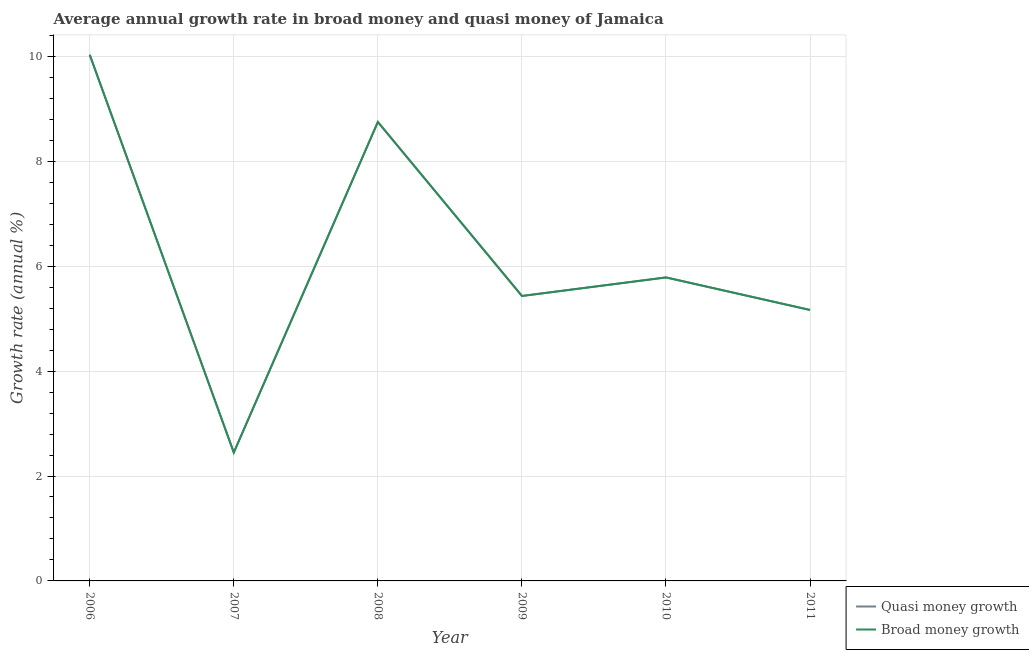Does the line corresponding to annual growth rate in quasi money intersect with the line corresponding to annual growth rate in broad money?
Provide a succinct answer. Yes. What is the annual growth rate in broad money in 2008?
Offer a terse response. 8.75. Across all years, what is the maximum annual growth rate in quasi money?
Ensure brevity in your answer.  10.03. Across all years, what is the minimum annual growth rate in broad money?
Your response must be concise. 2.45. In which year was the annual growth rate in broad money minimum?
Ensure brevity in your answer.  2007. What is the total annual growth rate in broad money in the graph?
Provide a short and direct response. 37.61. What is the difference between the annual growth rate in quasi money in 2006 and that in 2007?
Offer a terse response. 7.58. What is the difference between the annual growth rate in broad money in 2011 and the annual growth rate in quasi money in 2008?
Your answer should be very brief. -3.58. What is the average annual growth rate in broad money per year?
Make the answer very short. 6.27. In the year 2010, what is the difference between the annual growth rate in broad money and annual growth rate in quasi money?
Keep it short and to the point. 0. In how many years, is the annual growth rate in quasi money greater than 6 %?
Your response must be concise. 2. What is the ratio of the annual growth rate in broad money in 2007 to that in 2008?
Keep it short and to the point. 0.28. What is the difference between the highest and the second highest annual growth rate in quasi money?
Provide a succinct answer. 1.28. What is the difference between the highest and the lowest annual growth rate in quasi money?
Your response must be concise. 7.58. How many lines are there?
Your answer should be very brief. 2. How many years are there in the graph?
Your answer should be very brief. 6. What is the difference between two consecutive major ticks on the Y-axis?
Your response must be concise. 2. Are the values on the major ticks of Y-axis written in scientific E-notation?
Give a very brief answer. No. Where does the legend appear in the graph?
Your answer should be compact. Bottom right. What is the title of the graph?
Your answer should be very brief. Average annual growth rate in broad money and quasi money of Jamaica. What is the label or title of the Y-axis?
Give a very brief answer. Growth rate (annual %). What is the Growth rate (annual %) of Quasi money growth in 2006?
Your answer should be very brief. 10.03. What is the Growth rate (annual %) in Broad money growth in 2006?
Offer a very short reply. 10.03. What is the Growth rate (annual %) in Quasi money growth in 2007?
Your response must be concise. 2.45. What is the Growth rate (annual %) in Broad money growth in 2007?
Provide a succinct answer. 2.45. What is the Growth rate (annual %) of Quasi money growth in 2008?
Provide a succinct answer. 8.75. What is the Growth rate (annual %) of Broad money growth in 2008?
Provide a succinct answer. 8.75. What is the Growth rate (annual %) in Quasi money growth in 2009?
Ensure brevity in your answer.  5.43. What is the Growth rate (annual %) of Broad money growth in 2009?
Provide a short and direct response. 5.43. What is the Growth rate (annual %) in Quasi money growth in 2010?
Your answer should be very brief. 5.79. What is the Growth rate (annual %) in Broad money growth in 2010?
Your answer should be compact. 5.79. What is the Growth rate (annual %) of Quasi money growth in 2011?
Provide a succinct answer. 5.16. What is the Growth rate (annual %) of Broad money growth in 2011?
Give a very brief answer. 5.16. Across all years, what is the maximum Growth rate (annual %) of Quasi money growth?
Give a very brief answer. 10.03. Across all years, what is the maximum Growth rate (annual %) in Broad money growth?
Your answer should be compact. 10.03. Across all years, what is the minimum Growth rate (annual %) in Quasi money growth?
Give a very brief answer. 2.45. Across all years, what is the minimum Growth rate (annual %) of Broad money growth?
Keep it short and to the point. 2.45. What is the total Growth rate (annual %) in Quasi money growth in the graph?
Keep it short and to the point. 37.61. What is the total Growth rate (annual %) in Broad money growth in the graph?
Offer a very short reply. 37.61. What is the difference between the Growth rate (annual %) in Quasi money growth in 2006 and that in 2007?
Your answer should be very brief. 7.58. What is the difference between the Growth rate (annual %) in Broad money growth in 2006 and that in 2007?
Provide a succinct answer. 7.58. What is the difference between the Growth rate (annual %) of Quasi money growth in 2006 and that in 2008?
Provide a short and direct response. 1.28. What is the difference between the Growth rate (annual %) in Broad money growth in 2006 and that in 2008?
Make the answer very short. 1.28. What is the difference between the Growth rate (annual %) in Quasi money growth in 2006 and that in 2009?
Offer a terse response. 4.6. What is the difference between the Growth rate (annual %) in Broad money growth in 2006 and that in 2009?
Provide a succinct answer. 4.6. What is the difference between the Growth rate (annual %) in Quasi money growth in 2006 and that in 2010?
Your response must be concise. 4.24. What is the difference between the Growth rate (annual %) in Broad money growth in 2006 and that in 2010?
Ensure brevity in your answer.  4.24. What is the difference between the Growth rate (annual %) in Quasi money growth in 2006 and that in 2011?
Provide a short and direct response. 4.87. What is the difference between the Growth rate (annual %) of Broad money growth in 2006 and that in 2011?
Give a very brief answer. 4.87. What is the difference between the Growth rate (annual %) of Quasi money growth in 2007 and that in 2008?
Offer a terse response. -6.3. What is the difference between the Growth rate (annual %) in Broad money growth in 2007 and that in 2008?
Give a very brief answer. -6.3. What is the difference between the Growth rate (annual %) of Quasi money growth in 2007 and that in 2009?
Provide a succinct answer. -2.98. What is the difference between the Growth rate (annual %) of Broad money growth in 2007 and that in 2009?
Your response must be concise. -2.98. What is the difference between the Growth rate (annual %) in Quasi money growth in 2007 and that in 2010?
Offer a very short reply. -3.34. What is the difference between the Growth rate (annual %) of Broad money growth in 2007 and that in 2010?
Offer a terse response. -3.34. What is the difference between the Growth rate (annual %) of Quasi money growth in 2007 and that in 2011?
Ensure brevity in your answer.  -2.72. What is the difference between the Growth rate (annual %) in Broad money growth in 2007 and that in 2011?
Provide a succinct answer. -2.72. What is the difference between the Growth rate (annual %) in Quasi money growth in 2008 and that in 2009?
Offer a very short reply. 3.32. What is the difference between the Growth rate (annual %) in Broad money growth in 2008 and that in 2009?
Give a very brief answer. 3.32. What is the difference between the Growth rate (annual %) of Quasi money growth in 2008 and that in 2010?
Your answer should be compact. 2.96. What is the difference between the Growth rate (annual %) in Broad money growth in 2008 and that in 2010?
Keep it short and to the point. 2.96. What is the difference between the Growth rate (annual %) in Quasi money growth in 2008 and that in 2011?
Offer a very short reply. 3.58. What is the difference between the Growth rate (annual %) of Broad money growth in 2008 and that in 2011?
Offer a very short reply. 3.58. What is the difference between the Growth rate (annual %) in Quasi money growth in 2009 and that in 2010?
Your answer should be compact. -0.35. What is the difference between the Growth rate (annual %) of Broad money growth in 2009 and that in 2010?
Offer a terse response. -0.35. What is the difference between the Growth rate (annual %) in Quasi money growth in 2009 and that in 2011?
Keep it short and to the point. 0.27. What is the difference between the Growth rate (annual %) in Broad money growth in 2009 and that in 2011?
Offer a terse response. 0.27. What is the difference between the Growth rate (annual %) in Quasi money growth in 2010 and that in 2011?
Your answer should be compact. 0.62. What is the difference between the Growth rate (annual %) of Broad money growth in 2010 and that in 2011?
Provide a succinct answer. 0.62. What is the difference between the Growth rate (annual %) of Quasi money growth in 2006 and the Growth rate (annual %) of Broad money growth in 2007?
Offer a terse response. 7.58. What is the difference between the Growth rate (annual %) of Quasi money growth in 2006 and the Growth rate (annual %) of Broad money growth in 2008?
Offer a very short reply. 1.28. What is the difference between the Growth rate (annual %) of Quasi money growth in 2006 and the Growth rate (annual %) of Broad money growth in 2009?
Make the answer very short. 4.6. What is the difference between the Growth rate (annual %) in Quasi money growth in 2006 and the Growth rate (annual %) in Broad money growth in 2010?
Make the answer very short. 4.24. What is the difference between the Growth rate (annual %) in Quasi money growth in 2006 and the Growth rate (annual %) in Broad money growth in 2011?
Your response must be concise. 4.87. What is the difference between the Growth rate (annual %) in Quasi money growth in 2007 and the Growth rate (annual %) in Broad money growth in 2008?
Ensure brevity in your answer.  -6.3. What is the difference between the Growth rate (annual %) in Quasi money growth in 2007 and the Growth rate (annual %) in Broad money growth in 2009?
Make the answer very short. -2.98. What is the difference between the Growth rate (annual %) in Quasi money growth in 2007 and the Growth rate (annual %) in Broad money growth in 2010?
Your response must be concise. -3.34. What is the difference between the Growth rate (annual %) of Quasi money growth in 2007 and the Growth rate (annual %) of Broad money growth in 2011?
Your answer should be compact. -2.72. What is the difference between the Growth rate (annual %) in Quasi money growth in 2008 and the Growth rate (annual %) in Broad money growth in 2009?
Ensure brevity in your answer.  3.32. What is the difference between the Growth rate (annual %) in Quasi money growth in 2008 and the Growth rate (annual %) in Broad money growth in 2010?
Keep it short and to the point. 2.96. What is the difference between the Growth rate (annual %) in Quasi money growth in 2008 and the Growth rate (annual %) in Broad money growth in 2011?
Give a very brief answer. 3.58. What is the difference between the Growth rate (annual %) in Quasi money growth in 2009 and the Growth rate (annual %) in Broad money growth in 2010?
Keep it short and to the point. -0.35. What is the difference between the Growth rate (annual %) in Quasi money growth in 2009 and the Growth rate (annual %) in Broad money growth in 2011?
Offer a very short reply. 0.27. What is the difference between the Growth rate (annual %) in Quasi money growth in 2010 and the Growth rate (annual %) in Broad money growth in 2011?
Provide a succinct answer. 0.62. What is the average Growth rate (annual %) of Quasi money growth per year?
Offer a terse response. 6.27. What is the average Growth rate (annual %) in Broad money growth per year?
Give a very brief answer. 6.27. In the year 2006, what is the difference between the Growth rate (annual %) in Quasi money growth and Growth rate (annual %) in Broad money growth?
Provide a short and direct response. 0. In the year 2007, what is the difference between the Growth rate (annual %) of Quasi money growth and Growth rate (annual %) of Broad money growth?
Make the answer very short. 0. In the year 2008, what is the difference between the Growth rate (annual %) of Quasi money growth and Growth rate (annual %) of Broad money growth?
Keep it short and to the point. 0. In the year 2009, what is the difference between the Growth rate (annual %) of Quasi money growth and Growth rate (annual %) of Broad money growth?
Offer a terse response. 0. In the year 2010, what is the difference between the Growth rate (annual %) in Quasi money growth and Growth rate (annual %) in Broad money growth?
Make the answer very short. 0. What is the ratio of the Growth rate (annual %) in Quasi money growth in 2006 to that in 2007?
Offer a terse response. 4.1. What is the ratio of the Growth rate (annual %) of Broad money growth in 2006 to that in 2007?
Give a very brief answer. 4.1. What is the ratio of the Growth rate (annual %) in Quasi money growth in 2006 to that in 2008?
Offer a terse response. 1.15. What is the ratio of the Growth rate (annual %) of Broad money growth in 2006 to that in 2008?
Provide a succinct answer. 1.15. What is the ratio of the Growth rate (annual %) in Quasi money growth in 2006 to that in 2009?
Your answer should be very brief. 1.85. What is the ratio of the Growth rate (annual %) of Broad money growth in 2006 to that in 2009?
Your answer should be very brief. 1.85. What is the ratio of the Growth rate (annual %) in Quasi money growth in 2006 to that in 2010?
Your answer should be very brief. 1.73. What is the ratio of the Growth rate (annual %) in Broad money growth in 2006 to that in 2010?
Keep it short and to the point. 1.73. What is the ratio of the Growth rate (annual %) in Quasi money growth in 2006 to that in 2011?
Give a very brief answer. 1.94. What is the ratio of the Growth rate (annual %) in Broad money growth in 2006 to that in 2011?
Your answer should be very brief. 1.94. What is the ratio of the Growth rate (annual %) of Quasi money growth in 2007 to that in 2008?
Keep it short and to the point. 0.28. What is the ratio of the Growth rate (annual %) of Broad money growth in 2007 to that in 2008?
Your answer should be very brief. 0.28. What is the ratio of the Growth rate (annual %) in Quasi money growth in 2007 to that in 2009?
Make the answer very short. 0.45. What is the ratio of the Growth rate (annual %) in Broad money growth in 2007 to that in 2009?
Offer a very short reply. 0.45. What is the ratio of the Growth rate (annual %) of Quasi money growth in 2007 to that in 2010?
Make the answer very short. 0.42. What is the ratio of the Growth rate (annual %) in Broad money growth in 2007 to that in 2010?
Offer a terse response. 0.42. What is the ratio of the Growth rate (annual %) in Quasi money growth in 2007 to that in 2011?
Offer a terse response. 0.47. What is the ratio of the Growth rate (annual %) in Broad money growth in 2007 to that in 2011?
Ensure brevity in your answer.  0.47. What is the ratio of the Growth rate (annual %) in Quasi money growth in 2008 to that in 2009?
Keep it short and to the point. 1.61. What is the ratio of the Growth rate (annual %) of Broad money growth in 2008 to that in 2009?
Your response must be concise. 1.61. What is the ratio of the Growth rate (annual %) in Quasi money growth in 2008 to that in 2010?
Provide a short and direct response. 1.51. What is the ratio of the Growth rate (annual %) of Broad money growth in 2008 to that in 2010?
Provide a short and direct response. 1.51. What is the ratio of the Growth rate (annual %) of Quasi money growth in 2008 to that in 2011?
Offer a very short reply. 1.69. What is the ratio of the Growth rate (annual %) of Broad money growth in 2008 to that in 2011?
Provide a short and direct response. 1.69. What is the ratio of the Growth rate (annual %) of Quasi money growth in 2009 to that in 2010?
Provide a short and direct response. 0.94. What is the ratio of the Growth rate (annual %) of Broad money growth in 2009 to that in 2010?
Ensure brevity in your answer.  0.94. What is the ratio of the Growth rate (annual %) in Quasi money growth in 2009 to that in 2011?
Provide a short and direct response. 1.05. What is the ratio of the Growth rate (annual %) in Broad money growth in 2009 to that in 2011?
Make the answer very short. 1.05. What is the ratio of the Growth rate (annual %) of Quasi money growth in 2010 to that in 2011?
Provide a short and direct response. 1.12. What is the ratio of the Growth rate (annual %) in Broad money growth in 2010 to that in 2011?
Provide a succinct answer. 1.12. What is the difference between the highest and the second highest Growth rate (annual %) of Quasi money growth?
Provide a short and direct response. 1.28. What is the difference between the highest and the second highest Growth rate (annual %) in Broad money growth?
Offer a very short reply. 1.28. What is the difference between the highest and the lowest Growth rate (annual %) in Quasi money growth?
Provide a short and direct response. 7.58. What is the difference between the highest and the lowest Growth rate (annual %) of Broad money growth?
Offer a terse response. 7.58. 